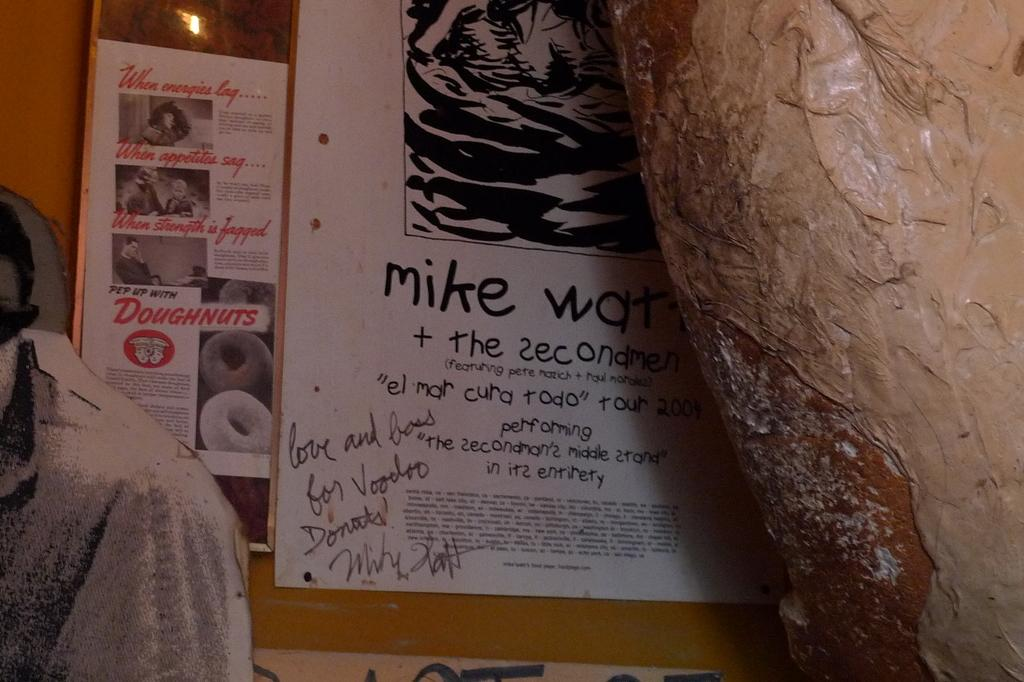What can be seen on the wall in the image? There are posts on the wall in the image. What is on the posts? There are objects on the posts. What is depicted on the posters? The posters have text, pictures of persons, and pictures of doughnuts. What type of stew is being served in the image? There is no stew present in the image; it features posters with text, pictures of persons, and pictures of doughnuts. Can you see any trains in the image? There are no trains visible in the image. 